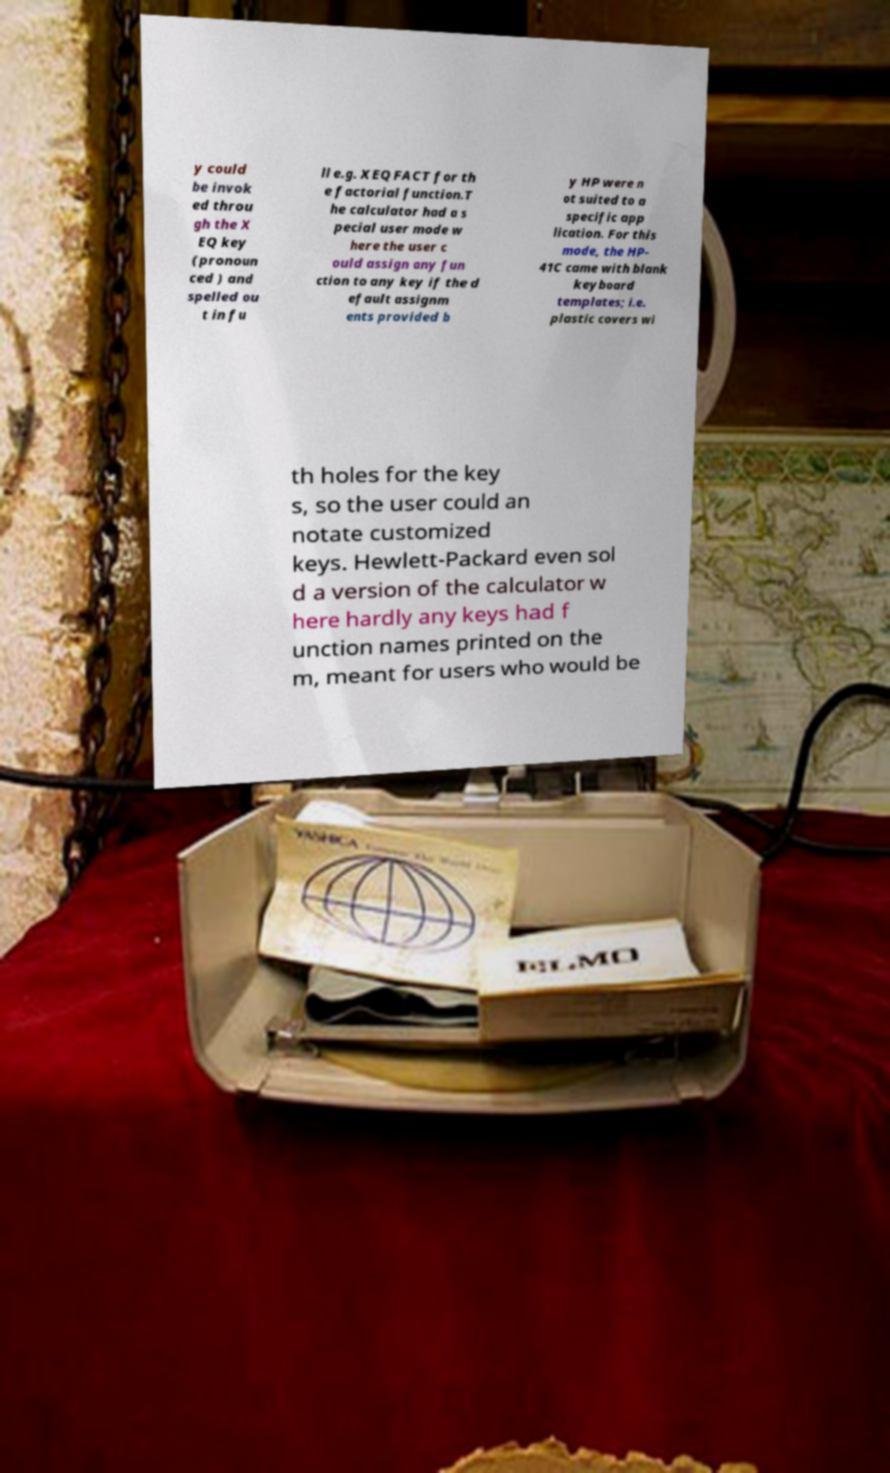I need the written content from this picture converted into text. Can you do that? y could be invok ed throu gh the X EQ key (pronoun ced ) and spelled ou t in fu ll e.g. XEQ FACT for th e factorial function.T he calculator had a s pecial user mode w here the user c ould assign any fun ction to any key if the d efault assignm ents provided b y HP were n ot suited to a specific app lication. For this mode, the HP- 41C came with blank keyboard templates; i.e. plastic covers wi th holes for the key s, so the user could an notate customized keys. Hewlett-Packard even sol d a version of the calculator w here hardly any keys had f unction names printed on the m, meant for users who would be 